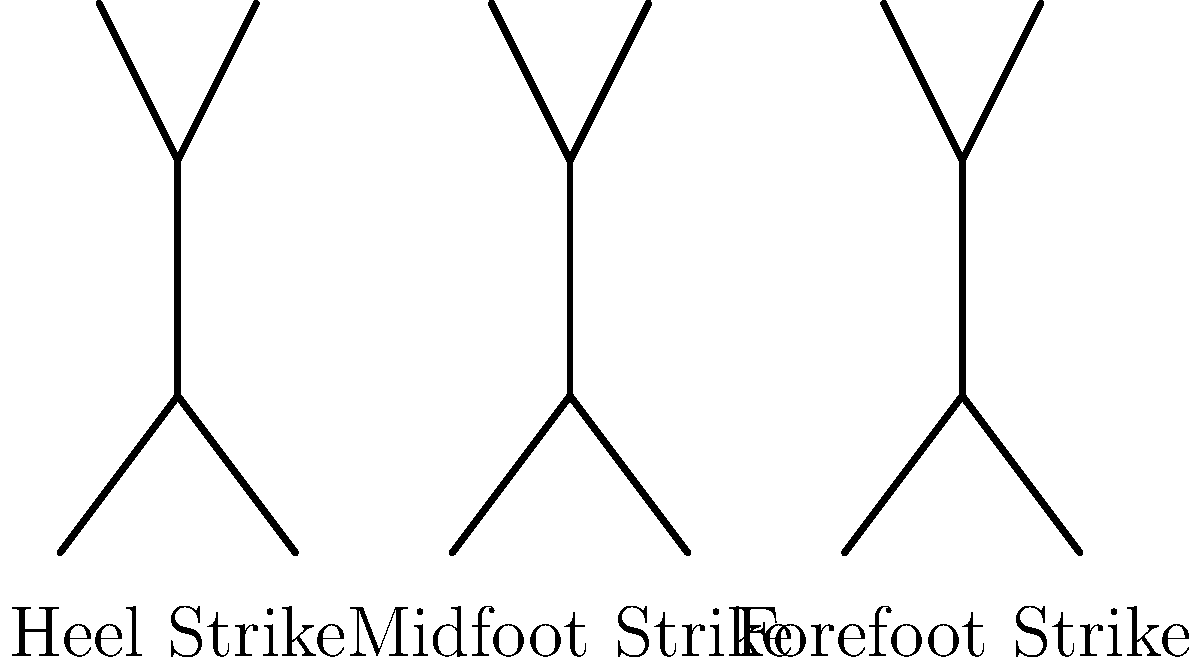Based on the stick figure animations and efficiency bars shown, which running technique appears to be the most efficient for an entrepreneur looking to optimize their running performance and conserve energy for other business activities? To determine the most efficient running technique, we need to analyze the stick figure animations and the corresponding efficiency bars:

1. Heel Strike:
   - Represented by the leftmost stick figure
   - Efficiency bar is the shortest, indicating the lowest efficiency
   - This technique often results in higher impact forces and increased energy expenditure

2. Midfoot Strike:
   - Represented by the middle stick figure
   - Efficiency bar is taller than the heel strike, suggesting improved efficiency
   - This technique provides a balance between impact absorption and forward propulsion

3. Forefoot Strike:
   - Represented by the rightmost stick figure
   - Efficiency bar is the tallest, indicating the highest efficiency
   - This technique allows for better energy return and reduced impact forces

For an entrepreneur looking to optimize running performance and conserve energy:

- The forefoot strike technique appears to be the most efficient based on the tallest efficiency bar.
- This technique allows for better energy conservation, which is crucial for an entrepreneur who needs to balance physical activity with other business demands.
- The improved efficiency can lead to longer running distances with less fatigue, potentially increasing overall productivity and well-being.

It's important to note that while the forefoot strike technique shows the highest efficiency in this diagram, individual biomechanics and preferences may vary. Entrepreneurs should consider consulting with a running coach or biomechanist to determine the best technique for their specific needs and body type.
Answer: Forefoot Strike 